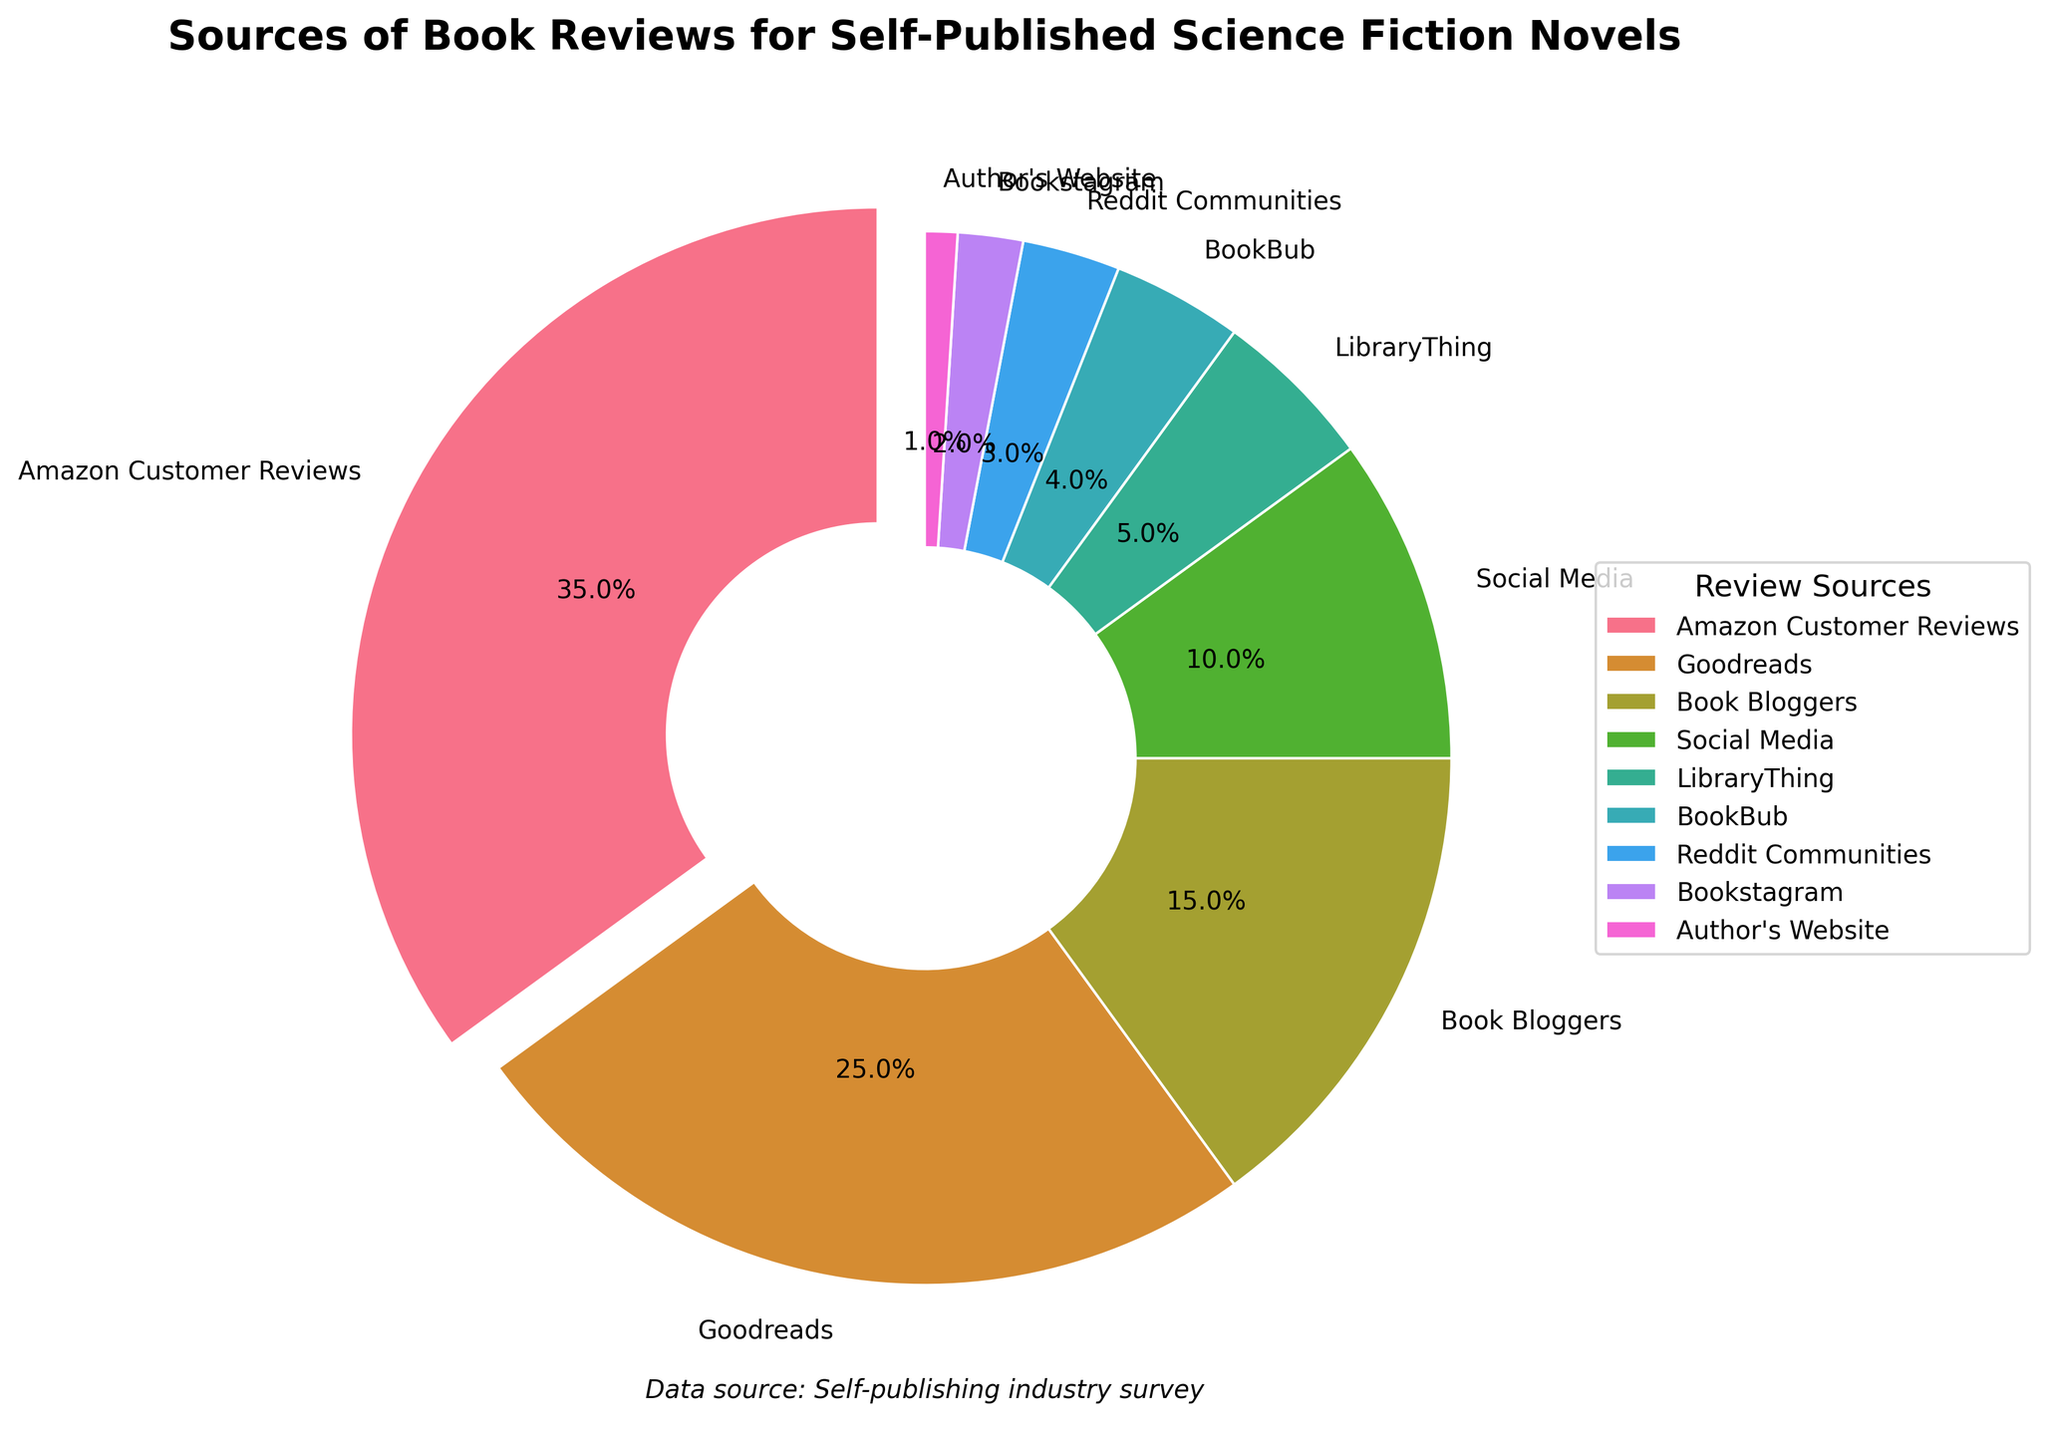Which source has the highest percentage of book reviews? The pie chart segments show that "Amazon Customer Reviews" has the segment with the largest size, and its label indicates a percentage of 35%.
Answer: Amazon Customer Reviews What is the combined percentage of book reviews from Social Media and Reddit Communities? According to the pie chart, Social Media has 10% and Reddit Communities has 3%. Adding these percentages together gives 10% + 3% = 13%.
Answer: 13% Are there more reviews from Goodreads or from Book Bloggers? The pie chart shows that Goodreads has a slice representing 25% and Book Bloggers have a slice representing 15%. Since 25% is greater than 15%, Goodreads has more reviews.
Answer: Goodreads What's the proportion of the smallest two sources combined relative to the whole? The two smallest slices are "Author's Website" with 1% and "Bookstagram" with 2%. Their combined percentage is 1% + 2% = 3%. Since the total is 100%, 3% of the whole is the proportion of the two smallest sources.
Answer: 3% What is the difference in percentages between the largest and the smallest source of reviews? "Amazon Customer Reviews" is the largest source with 35%, and "Author's Website" is the smallest with 1%. The difference is calculated as 35% - 1% = 34%.
Answer: 34% Which sources have a percentage of book reviews that are less than 5%? The categories that are less than 5% include LibraryThing (5%), BookBub (4%), Reddit Communities (3%), Bookstagram (2%), and Author's Website (1%). Excluding exactly 5%, the sources are BookBub, Reddit Communities, Bookstagram, and Author's Website.
Answer: BookBub, Reddit Communities, Bookstagram, Author's Website If you add the percentages of Goodreads and Book Bloggers, how does it compare to Amazon Customer Reviews? Goodreads has 25% and Book Bloggers have 15%. Adding these, 25% + 15% = 40%. Amazon Customer Reviews have 35%. Since 40% is greater than 35%, the combination is greater than Amazon Customer Reviews.
Answer: Greater What percentage of book reviews come from sources other than Amazon Customer Reviews and Goodreads? The total for Amazon Customer Reviews and Goodreads together is 35% + 25% = 60%. Subtracting from the whole (100%) gives the remaining reviews: 100% - 60% = 40%.
Answer: 40% Are there more reviews from Bookstagram or from BookBub? The pie chart shows that Bookstagram has a segment with 2%, while BookBub has a segment with 4%. Since 4% is greater than 2%, BookBub has more reviews.
Answer: BookBub 